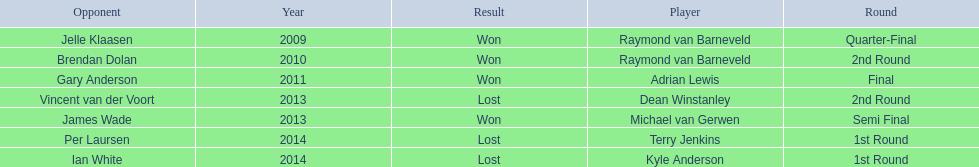What was the names of all the players? Raymond van Barneveld, Raymond van Barneveld, Adrian Lewis, Dean Winstanley, Michael van Gerwen, Terry Jenkins, Kyle Anderson. What years were the championship offered? 2009, 2010, 2011, 2013, 2013, 2014, 2014. Of these, who played in 2011? Adrian Lewis. 